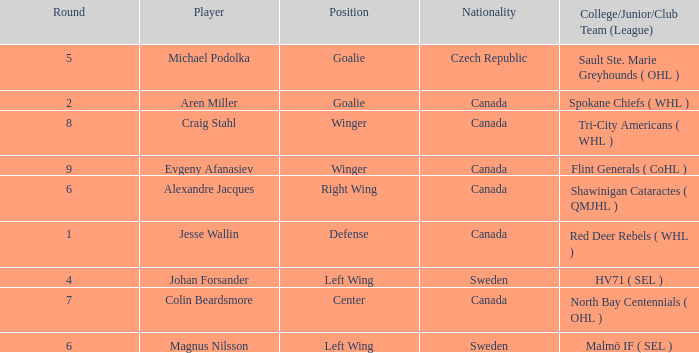What is the Nationality for alexandre jacques? Canada. 